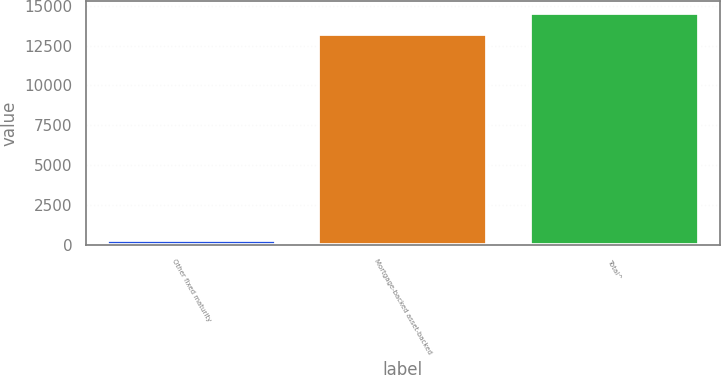<chart> <loc_0><loc_0><loc_500><loc_500><bar_chart><fcel>Other fixed maturity<fcel>Mortgage-backed asset-backed<fcel>Total^<nl><fcel>306<fcel>13220<fcel>14542<nl></chart> 